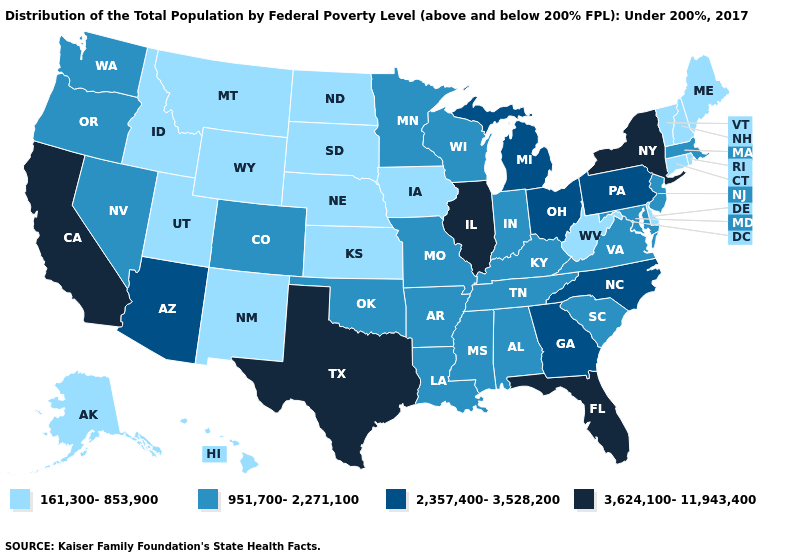How many symbols are there in the legend?
Short answer required. 4. Name the states that have a value in the range 951,700-2,271,100?
Quick response, please. Alabama, Arkansas, Colorado, Indiana, Kentucky, Louisiana, Maryland, Massachusetts, Minnesota, Mississippi, Missouri, Nevada, New Jersey, Oklahoma, Oregon, South Carolina, Tennessee, Virginia, Washington, Wisconsin. Among the states that border New Mexico , does Texas have the highest value?
Quick response, please. Yes. What is the value of New Jersey?
Quick response, please. 951,700-2,271,100. What is the value of Vermont?
Write a very short answer. 161,300-853,900. Among the states that border Vermont , which have the lowest value?
Keep it brief. New Hampshire. Among the states that border Ohio , which have the highest value?
Short answer required. Michigan, Pennsylvania. Among the states that border Wisconsin , does Illinois have the lowest value?
Write a very short answer. No. What is the lowest value in the MidWest?
Quick response, please. 161,300-853,900. What is the value of Georgia?
Write a very short answer. 2,357,400-3,528,200. Name the states that have a value in the range 951,700-2,271,100?
Quick response, please. Alabama, Arkansas, Colorado, Indiana, Kentucky, Louisiana, Maryland, Massachusetts, Minnesota, Mississippi, Missouri, Nevada, New Jersey, Oklahoma, Oregon, South Carolina, Tennessee, Virginia, Washington, Wisconsin. Does Arkansas have the highest value in the South?
Answer briefly. No. Does Tennessee have a lower value than North Carolina?
Give a very brief answer. Yes. Does Arkansas have a higher value than Iowa?
Keep it brief. Yes. 